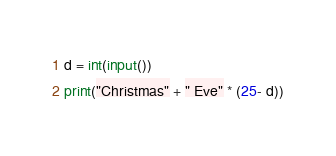<code> <loc_0><loc_0><loc_500><loc_500><_Python_>d = int(input())
print("Christmas" + " Eve" * (25- d))</code> 